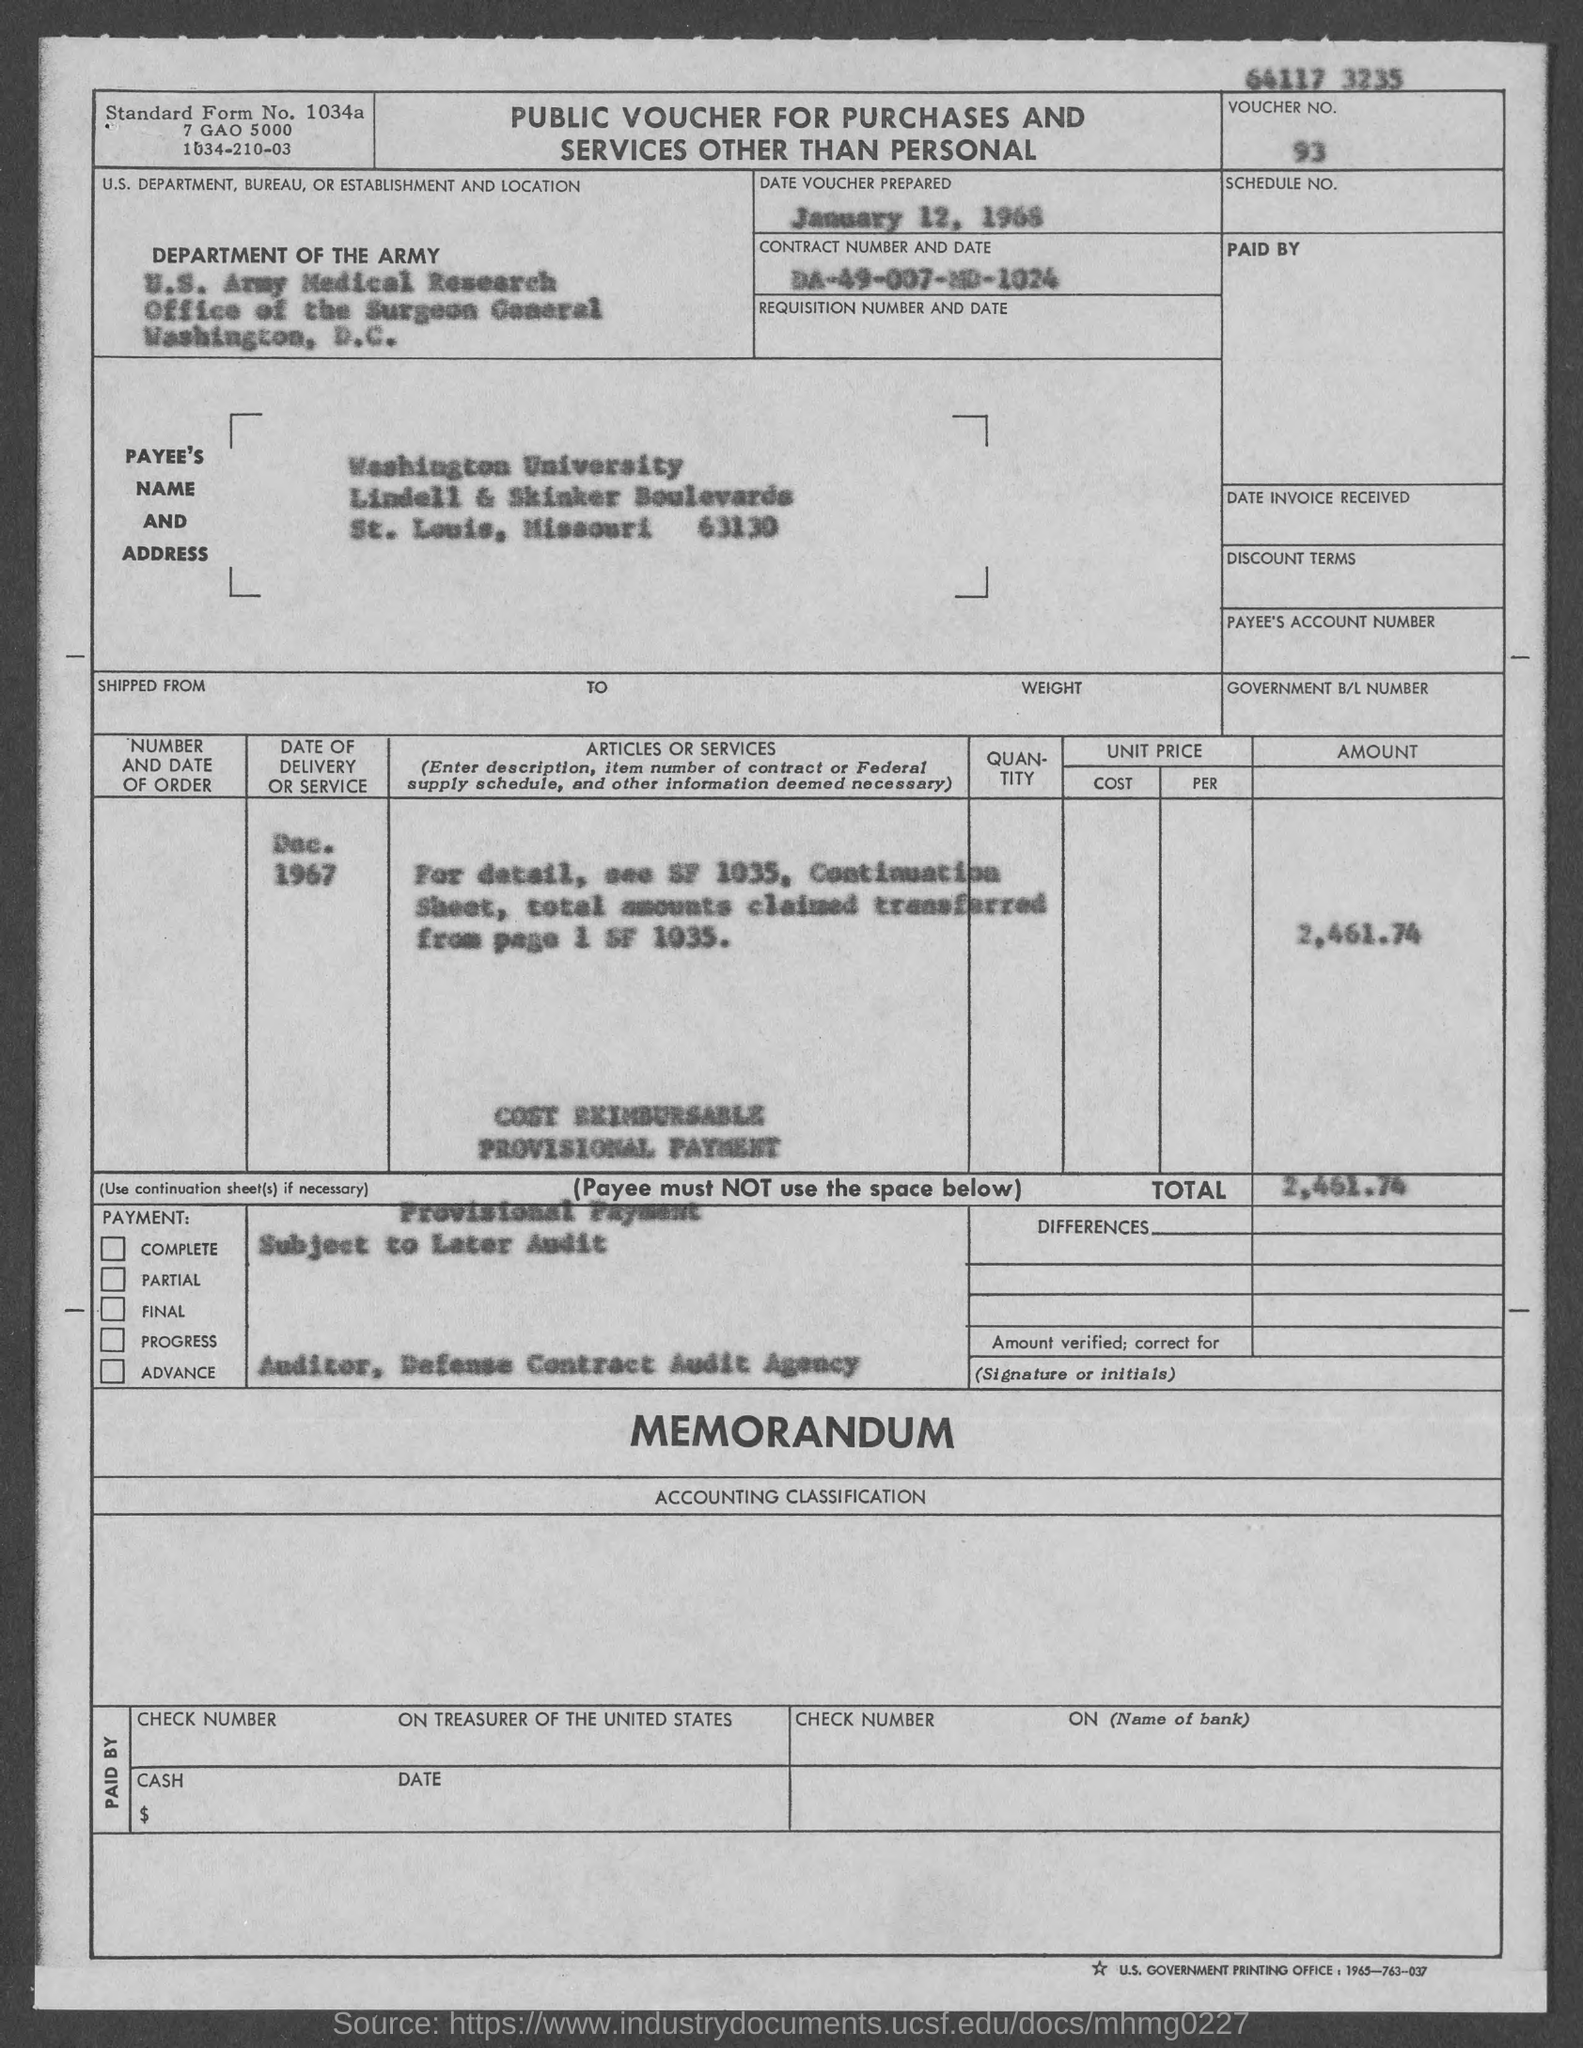What is the main heading of the Document?
Your answer should be very brief. Public Voucher for Purchases and services other than personal. What is the date of "delivery or service"?
Provide a succinct answer. DEC. 1967. What is voucher no.?
Offer a terse response. 93. What is the total cost?
Provide a short and direct response. 2,461.74. 